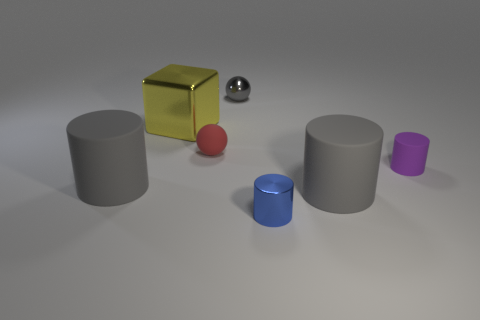How many big metallic things are the same shape as the tiny gray object?
Offer a very short reply. 0. What size is the purple cylinder that is the same material as the red object?
Provide a short and direct response. Small. Are there more blue cylinders than small spheres?
Make the answer very short. No. What color is the big shiny thing that is in front of the small gray ball?
Your answer should be compact. Yellow. There is a metal object that is right of the red rubber thing and in front of the metallic sphere; what is its size?
Provide a short and direct response. Small. How many other blue things have the same size as the blue thing?
Make the answer very short. 0. There is another object that is the same shape as the tiny gray object; what is its material?
Provide a succinct answer. Rubber. Do the purple matte object and the blue object have the same shape?
Provide a short and direct response. Yes. There is a big yellow object; how many large matte objects are in front of it?
Provide a short and direct response. 2. What is the shape of the gray rubber thing behind the big gray rubber cylinder that is on the right side of the big metallic block?
Offer a terse response. Cylinder. 